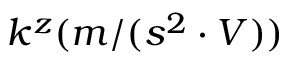Convert formula to latex. <formula><loc_0><loc_0><loc_500><loc_500>k ^ { z } ( m / ( s ^ { 2 } \cdot V ) )</formula> 